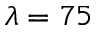Convert formula to latex. <formula><loc_0><loc_0><loc_500><loc_500>\lambda = 7 5</formula> 